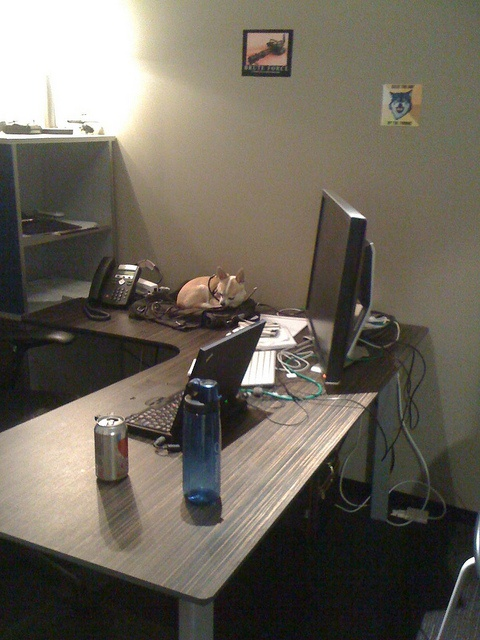Describe the objects in this image and their specific colors. I can see tv in white, black, and gray tones, laptop in white, black, gray, and darkgray tones, chair in white, black, gray, and darkgreen tones, bottle in white, black, gray, navy, and blue tones, and tv in white, black, gray, and darkgray tones in this image. 